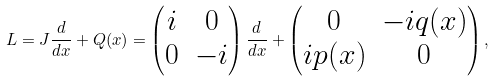<formula> <loc_0><loc_0><loc_500><loc_500>L = J \frac { d } { d x } + Q ( x ) = \begin{pmatrix} i & 0 \\ 0 & - i \end{pmatrix} \frac { d } { d x } + \begin{pmatrix} 0 & - i q ( x ) \\ i p ( x ) & 0 \end{pmatrix} ,</formula> 